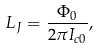<formula> <loc_0><loc_0><loc_500><loc_500>L _ { J } = \frac { \Phi _ { 0 } } { 2 \pi I _ { c 0 } } ,</formula> 